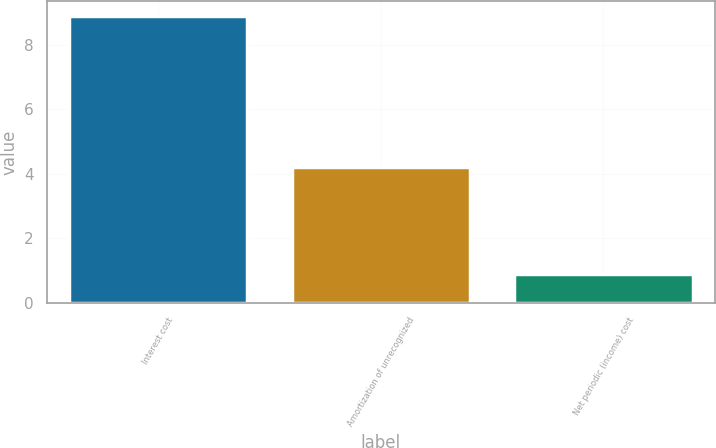Convert chart to OTSL. <chart><loc_0><loc_0><loc_500><loc_500><bar_chart><fcel>Interest cost<fcel>Amortization of unrecognized<fcel>Net periodic (income) cost<nl><fcel>8.9<fcel>4.2<fcel>0.9<nl></chart> 